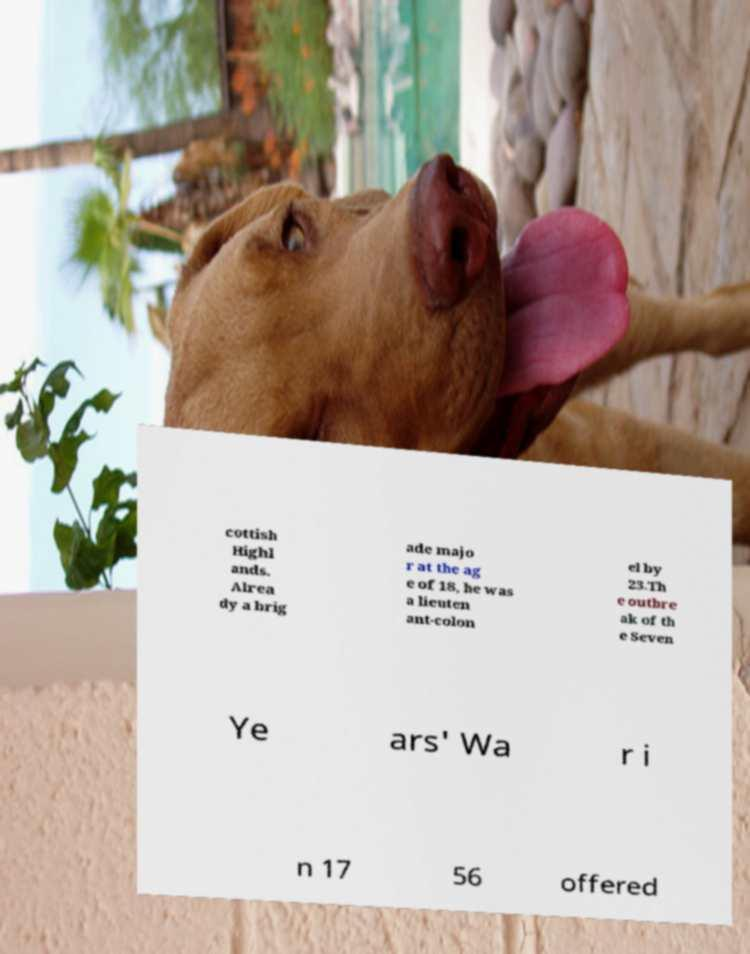What messages or text are displayed in this image? I need them in a readable, typed format. cottish Highl ands. Alrea dy a brig ade majo r at the ag e of 18, he was a lieuten ant-colon el by 23.Th e outbre ak of th e Seven Ye ars' Wa r i n 17 56 offered 